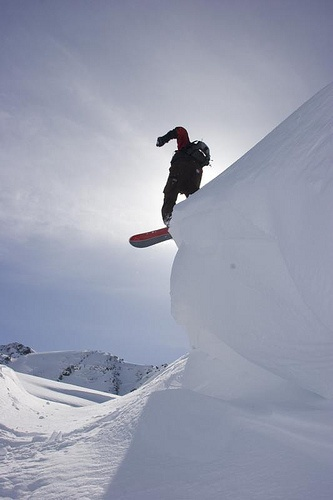Describe the objects in this image and their specific colors. I can see people in gray, black, maroon, and darkgray tones, snowboard in gray, maroon, purple, and black tones, and backpack in gray, black, white, and darkgray tones in this image. 